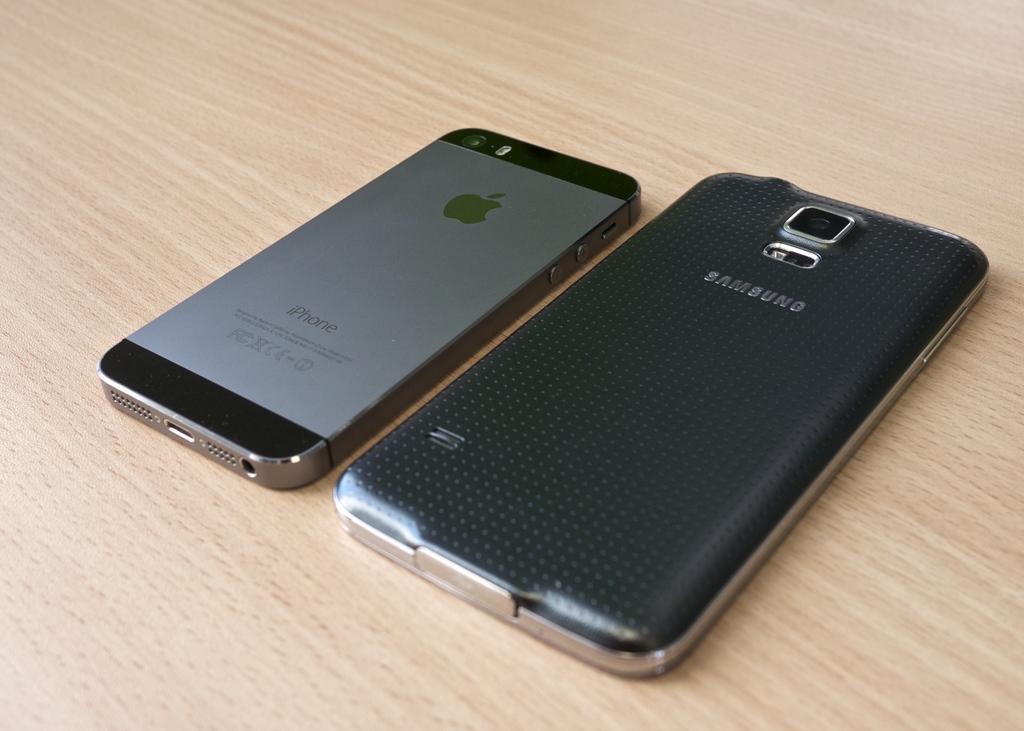What brands are these phones?
Provide a short and direct response. Samsung and apple. What is the brand of phone on the right?
Offer a terse response. Samsung. 